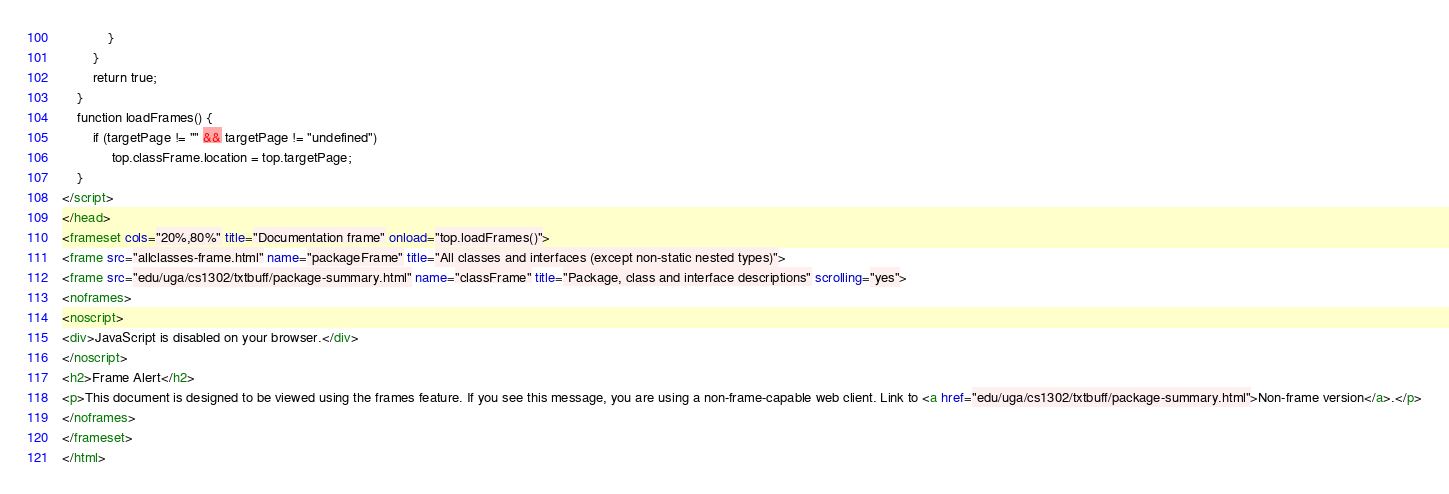<code> <loc_0><loc_0><loc_500><loc_500><_HTML_>            }
        }
        return true;
    }
    function loadFrames() {
        if (targetPage != "" && targetPage != "undefined")
             top.classFrame.location = top.targetPage;
    }
</script>
</head>
<frameset cols="20%,80%" title="Documentation frame" onload="top.loadFrames()">
<frame src="allclasses-frame.html" name="packageFrame" title="All classes and interfaces (except non-static nested types)">
<frame src="edu/uga/cs1302/txtbuff/package-summary.html" name="classFrame" title="Package, class and interface descriptions" scrolling="yes">
<noframes>
<noscript>
<div>JavaScript is disabled on your browser.</div>
</noscript>
<h2>Frame Alert</h2>
<p>This document is designed to be viewed using the frames feature. If you see this message, you are using a non-frame-capable web client. Link to <a href="edu/uga/cs1302/txtbuff/package-summary.html">Non-frame version</a>.</p>
</noframes>
</frameset>
</html>
</code> 